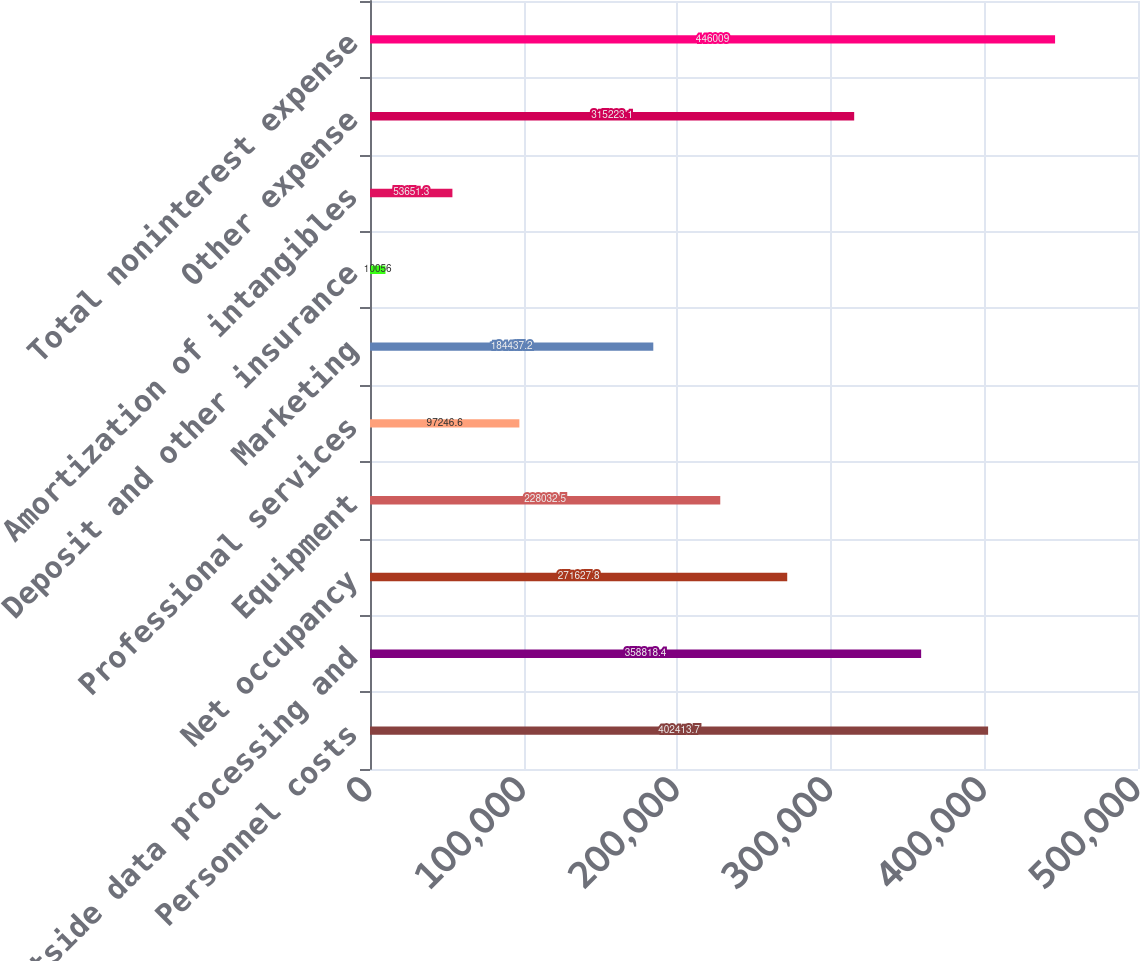<chart> <loc_0><loc_0><loc_500><loc_500><bar_chart><fcel>Personnel costs<fcel>Outside data processing and<fcel>Net occupancy<fcel>Equipment<fcel>Professional services<fcel>Marketing<fcel>Deposit and other insurance<fcel>Amortization of intangibles<fcel>Other expense<fcel>Total noninterest expense<nl><fcel>402414<fcel>358818<fcel>271628<fcel>228032<fcel>97246.6<fcel>184437<fcel>10056<fcel>53651.3<fcel>315223<fcel>446009<nl></chart> 